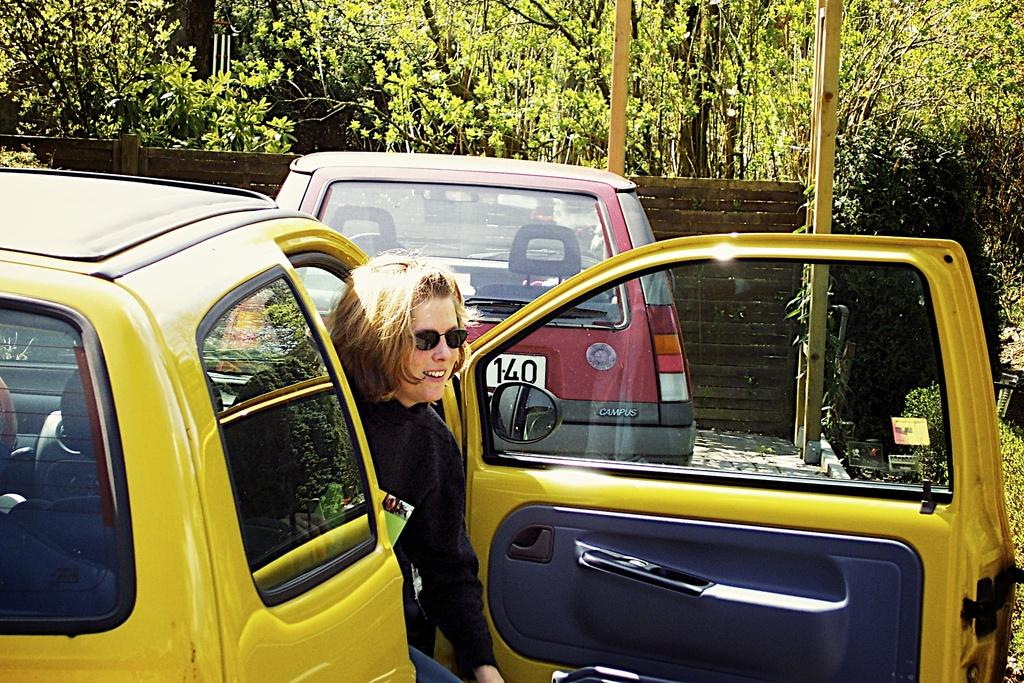<image>
Offer a succinct explanation of the picture presented. a lady in a yellow car behind a car that has 140 on it 